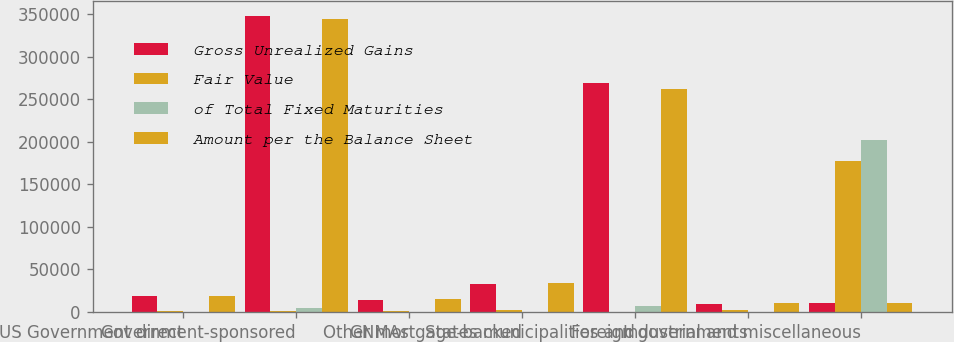<chart> <loc_0><loc_0><loc_500><loc_500><stacked_bar_chart><ecel><fcel>US Government direct<fcel>Government-sponsored<fcel>GNMAs<fcel>Other mortgage-backed<fcel>States municipalities and<fcel>Foreign governments<fcel>Industrial and miscellaneous<nl><fcel>Gross Unrealized Gains<fcel>18189<fcel>347555<fcel>14393<fcel>32322<fcel>268969<fcel>9348<fcel>10129<nl><fcel>Fair Value<fcel>463<fcel>1311<fcel>1287<fcel>1724<fcel>364<fcel>1641<fcel>176911<nl><fcel>of Total Fixed Maturities<fcel>1<fcel>4936<fcel>0<fcel>0<fcel>7013<fcel>79<fcel>202325<nl><fcel>Amount per the Balance Sheet<fcel>18651<fcel>343930<fcel>15680<fcel>34046<fcel>262320<fcel>10910<fcel>10129<nl></chart> 